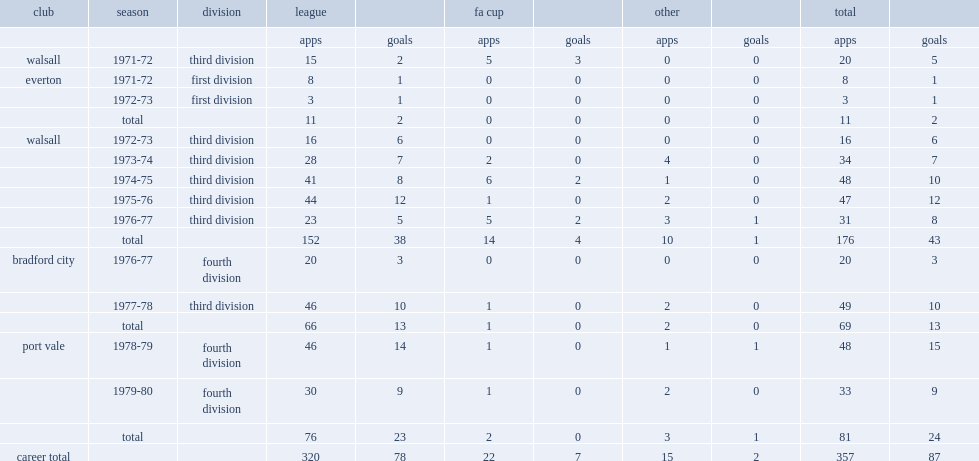Could you parse the entire table as a dict? {'header': ['club', 'season', 'division', 'league', '', 'fa cup', '', 'other', '', 'total', ''], 'rows': [['', '', '', 'apps', 'goals', 'apps', 'goals', 'apps', 'goals', 'apps', 'goals'], ['walsall', '1971-72', 'third division', '15', '2', '5', '3', '0', '0', '20', '5'], ['everton', '1971-72', 'first division', '8', '1', '0', '0', '0', '0', '8', '1'], ['', '1972-73', 'first division', '3', '1', '0', '0', '0', '0', '3', '1'], ['', 'total', '', '11', '2', '0', '0', '0', '0', '11', '2'], ['walsall', '1972-73', 'third division', '16', '6', '0', '0', '0', '0', '16', '6'], ['', '1973-74', 'third division', '28', '7', '2', '0', '4', '0', '34', '7'], ['', '1974-75', 'third division', '41', '8', '6', '2', '1', '0', '48', '10'], ['', '1975-76', 'third division', '44', '12', '1', '0', '2', '0', '47', '12'], ['', '1976-77', 'third division', '23', '5', '5', '2', '3', '1', '31', '8'], ['', 'total', '', '152', '38', '14', '4', '10', '1', '176', '43'], ['bradford city', '1976-77', 'fourth division', '20', '3', '0', '0', '0', '0', '20', '3'], ['', '1977-78', 'third division', '46', '10', '1', '0', '2', '0', '49', '10'], ['', 'total', '', '66', '13', '1', '0', '2', '0', '69', '13'], ['port vale', '1978-79', 'fourth division', '46', '14', '1', '0', '1', '1', '48', '15'], ['', '1979-80', 'fourth division', '30', '9', '1', '0', '2', '0', '33', '9'], ['', 'total', '', '76', '23', '2', '0', '3', '1', '81', '24'], ['career total', '', '', '320', '78', '22', '7', '15', '2', '357', '87']]} Which league did bernie wright transfer to bradford city in 1976-77? Fourth division. 